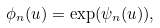<formula> <loc_0><loc_0><loc_500><loc_500>\phi _ { n } ( u ) = \exp ( \psi _ { n } ( u ) ) ,</formula> 